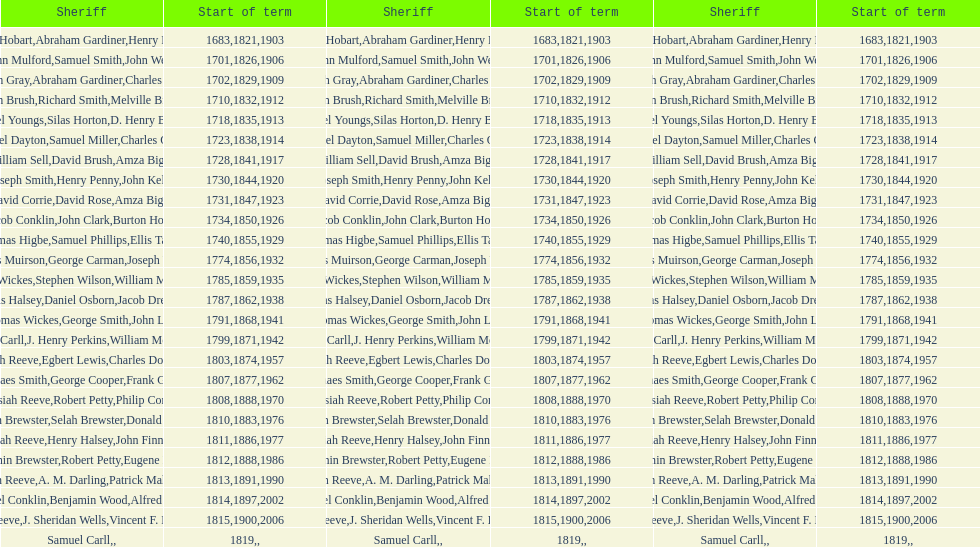When was the commencement of the initial sheriff's term? 1683. 